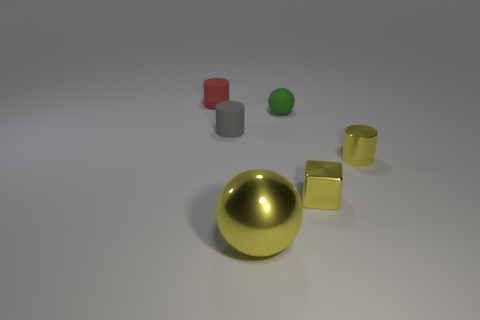Is the number of large things that are on the right side of the green matte object less than the number of small red blocks?
Keep it short and to the point. No. Are there any large purple matte objects?
Ensure brevity in your answer.  No. What color is the tiny shiny object that is the same shape as the gray rubber thing?
Offer a terse response. Yellow. There is a small rubber cylinder in front of the tiny red rubber object; is its color the same as the tiny rubber ball?
Your answer should be compact. No. Does the block have the same size as the yellow sphere?
Your answer should be very brief. No. There is a red object that is made of the same material as the tiny gray cylinder; what shape is it?
Make the answer very short. Cylinder. What number of other objects are there of the same shape as the green rubber thing?
Ensure brevity in your answer.  1. The tiny yellow metal thing to the left of the cylinder that is to the right of the sphere in front of the yellow metal cylinder is what shape?
Provide a succinct answer. Cube. What number of cubes are either small yellow metal things or cyan metal objects?
Offer a very short reply. 1. Is there a big yellow shiny ball that is on the left side of the cylinder behind the gray rubber cylinder?
Your answer should be very brief. No. 